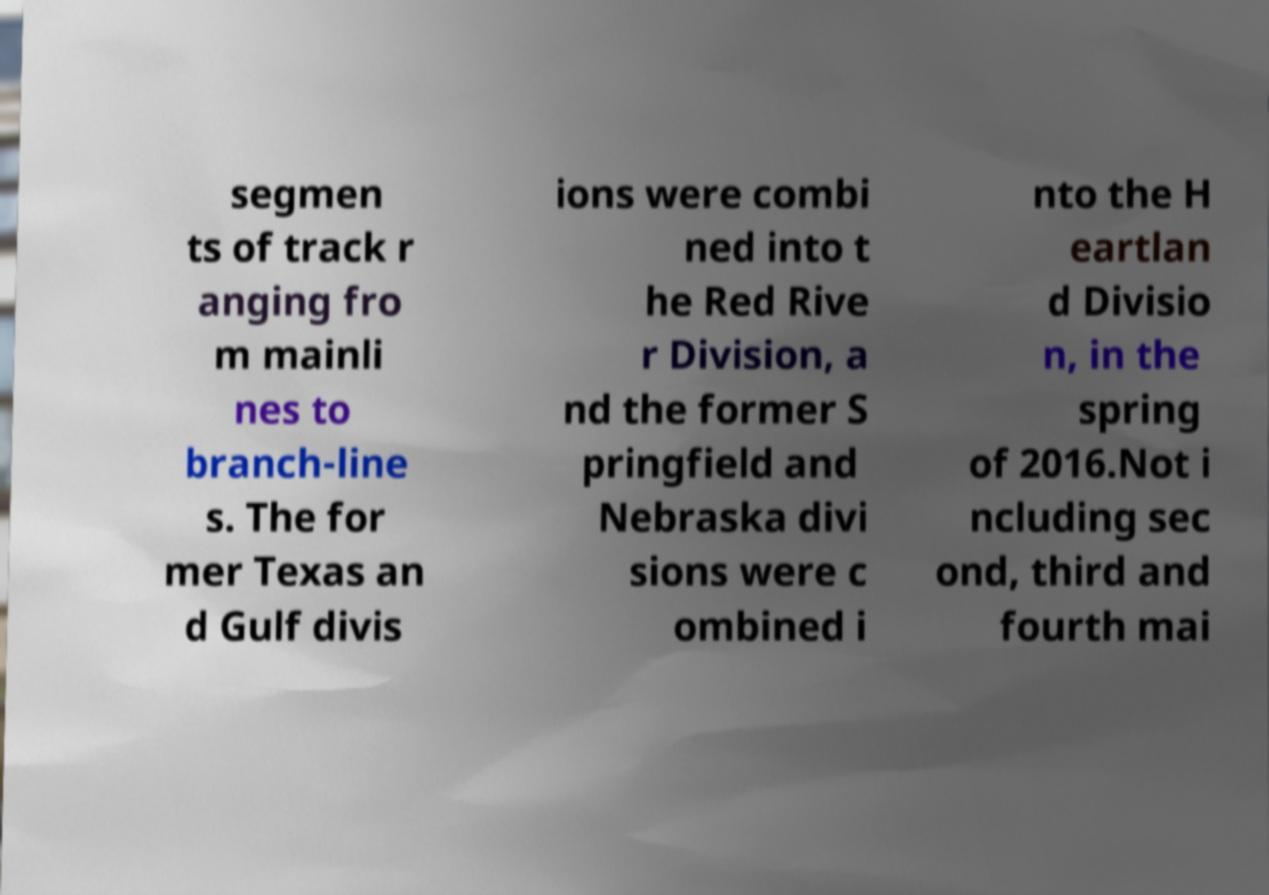I need the written content from this picture converted into text. Can you do that? segmen ts of track r anging fro m mainli nes to branch-line s. The for mer Texas an d Gulf divis ions were combi ned into t he Red Rive r Division, a nd the former S pringfield and Nebraska divi sions were c ombined i nto the H eartlan d Divisio n, in the spring of 2016.Not i ncluding sec ond, third and fourth mai 